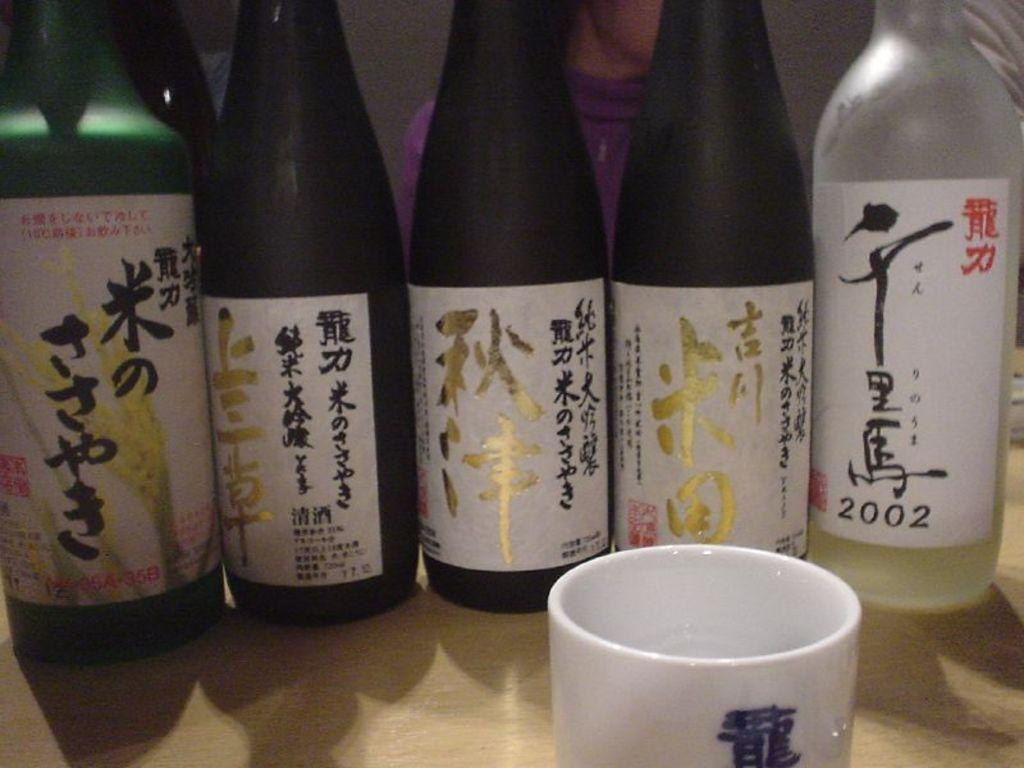What type of beverage containers are present in the image? There are many wine bottles in the image. What other type of container can be seen in the image? There is a cup in the image. Where are all the objects located in the image? All the objects are on a table. What type of vegetable is being used to create a coil in the image? There is no vegetable or coil present in the image. What is the weather like in the image? The image does not provide any information about the weather. 